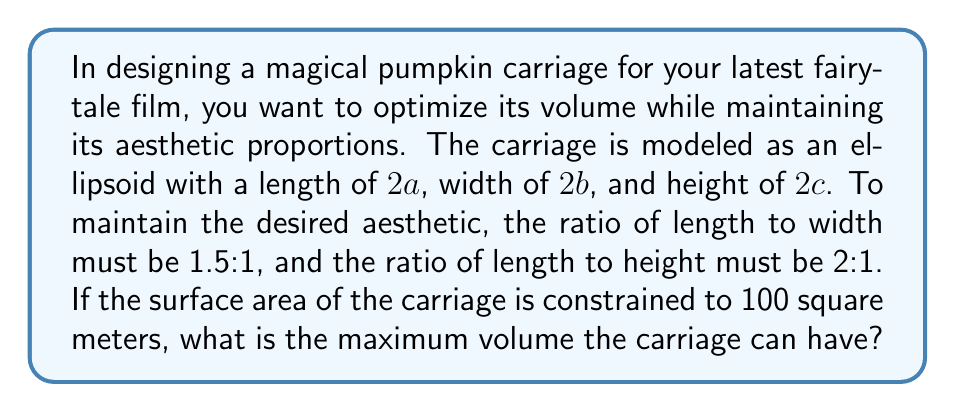Show me your answer to this math problem. Let's approach this step-by-step:

1) The volume of an ellipsoid is given by:
   $$V = \frac{4}{3}\pi abc$$

2) The surface area of an ellipsoid is approximated by:
   $$S \approx 4\pi\left(\frac{(ab)^{1.6} + (ac)^{1.6} + (bc)^{1.6}}{3}\right)^{\frac{1}{1.6}}$$

3) Given the aesthetic constraints:
   $a = 1.5b$ and $a = 2c$

4) Substituting these into the volume equation:
   $$V = \frac{4}{3}\pi a(a/1.5)(a/2) = \frac{4}{9}\pi a^3$$

5) For the surface area, we have:
   $$100 \approx 4\pi\left(\frac{(a \cdot a/1.5)^{1.6} + (a \cdot a/2)^{1.6} + (a/1.5 \cdot a/2)^{1.6}}{3}\right)^{\frac{1}{1.6}}$$

6) Simplifying:
   $$100 \approx 4\pi\left(\frac{(2a^2/3)^{1.6} + (a^2/2)^{1.6} + (a^2/3)^{1.6}}{3}\right)^{\frac{1}{1.6}}$$

7) Solving this numerically (as it's too complex for analytical solution), we get:
   $a \approx 3.78$ meters

8) Substituting this back into the volume equation:
   $$V = \frac{4}{9}\pi (3.78)^3 \approx 113.1$$ cubic meters
Answer: 113.1 cubic meters 